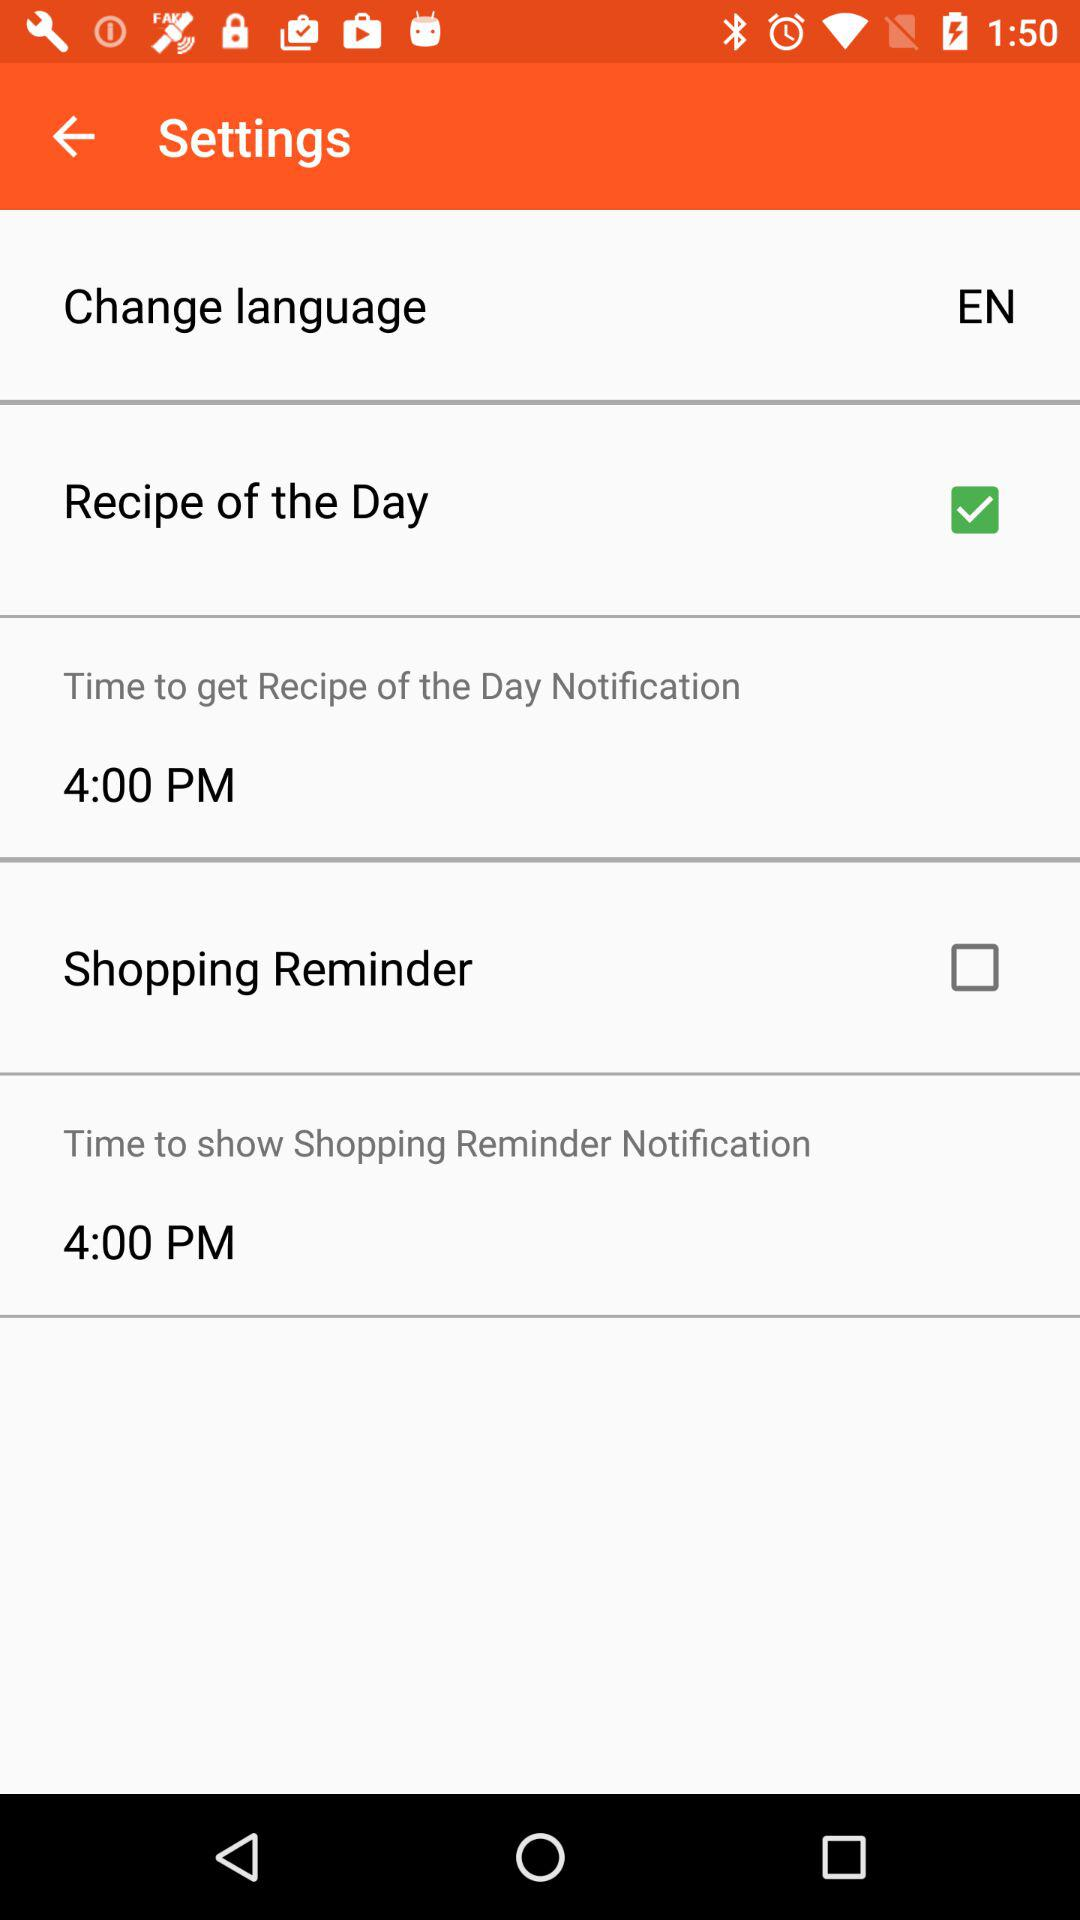Which time is selected to show the shopping reminder notification? The selected time is 4:00 PM. 